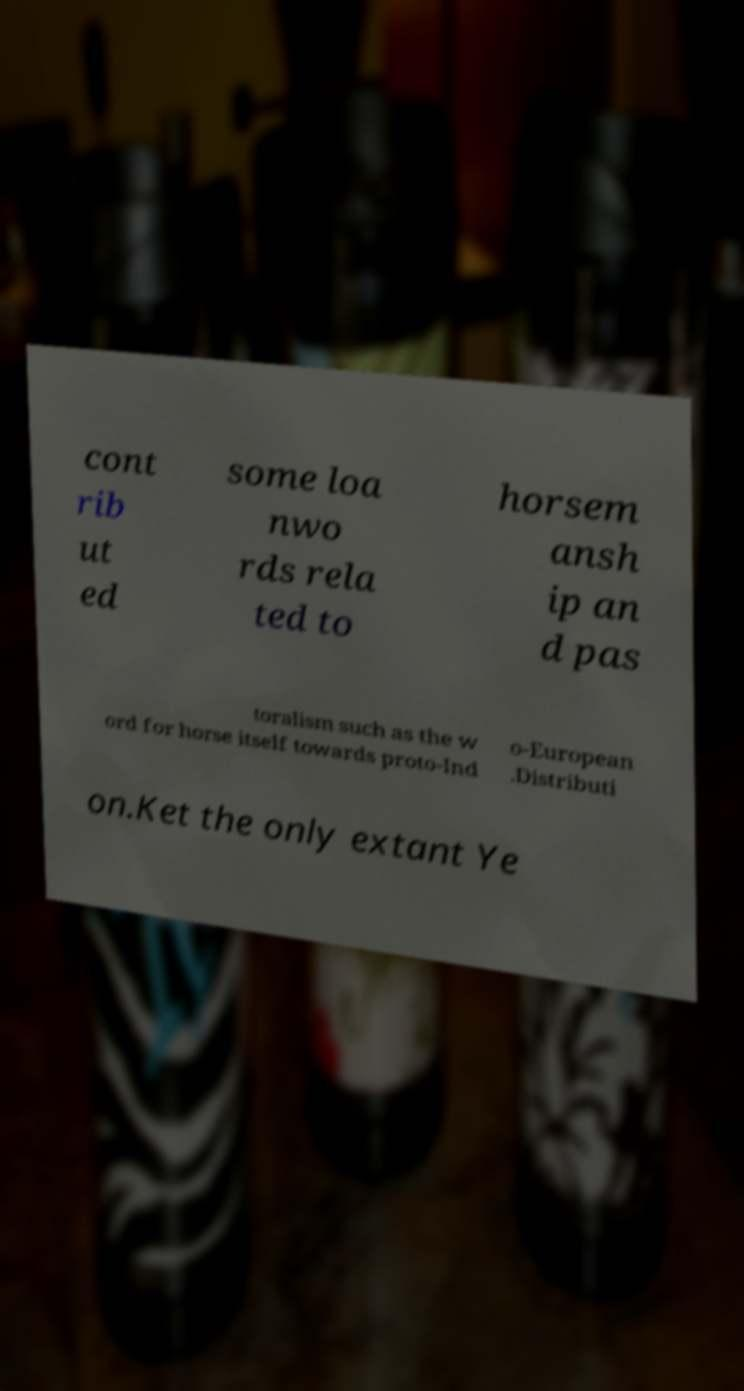Could you assist in decoding the text presented in this image and type it out clearly? cont rib ut ed some loa nwo rds rela ted to horsem ansh ip an d pas toralism such as the w ord for horse itself towards proto-Ind o-European .Distributi on.Ket the only extant Ye 